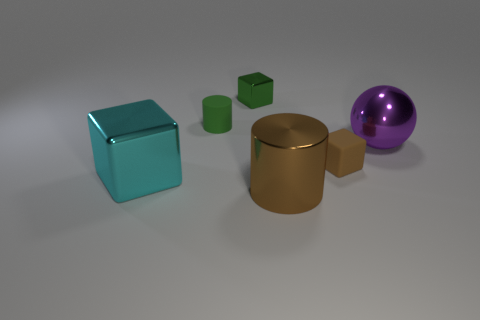Is there any other thing that is the same shape as the small green metal object?
Offer a terse response. Yes. There is a tiny cube that is the same material as the large sphere; what color is it?
Provide a short and direct response. Green. Are there any metal objects behind the tiny metal block that is behind the tiny cube that is in front of the purple metallic object?
Make the answer very short. No. Is the number of large purple balls that are on the right side of the large sphere less than the number of large brown shiny things that are behind the cyan metal thing?
Your answer should be compact. No. What number of balls are the same material as the large cyan block?
Keep it short and to the point. 1. There is a brown rubber block; is it the same size as the cylinder behind the metal cylinder?
Give a very brief answer. Yes. There is a cylinder that is the same color as the small shiny block; what is its material?
Provide a succinct answer. Rubber. What is the size of the thing behind the green object that is in front of the metal cube that is to the right of the large metal block?
Keep it short and to the point. Small. Is the number of purple spheres that are in front of the purple metallic object greater than the number of cubes that are in front of the big block?
Your answer should be very brief. No. There is a brown thing behind the big cyan metal thing; how many big cyan metallic things are on the right side of it?
Offer a very short reply. 0. 